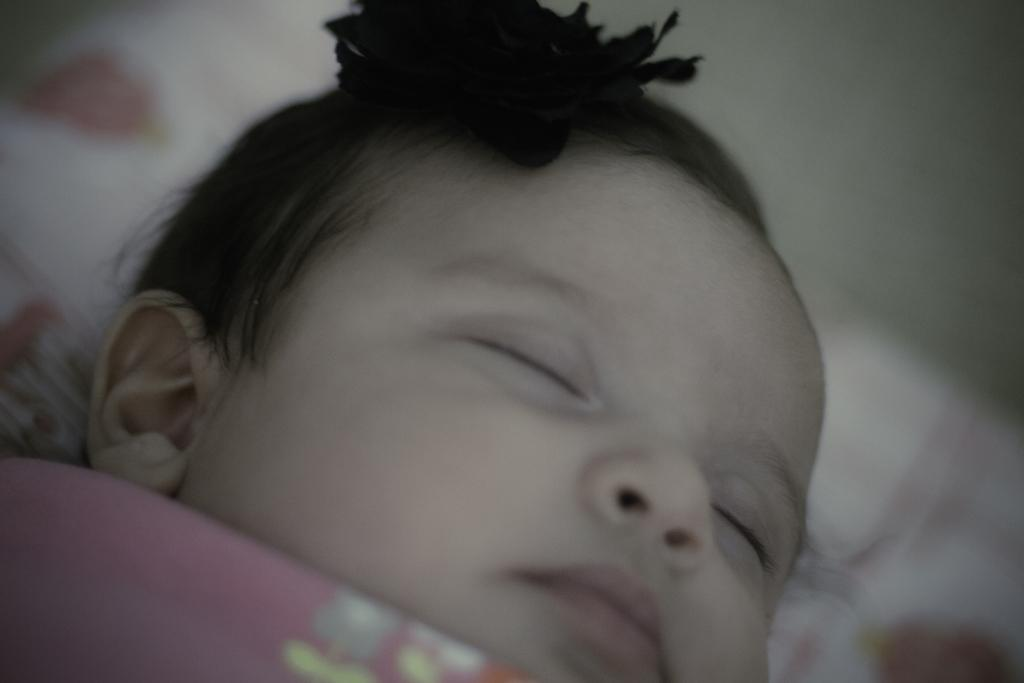What is the main subject of the image? The main subject of the image is a baby. What is the baby doing in the image? The baby is sleeping in the image. Where is the baby located in the image? The baby is in the center of the image. What advice does the baby's grandmother give in the image? There is no grandmother present in the image, and therefore no advice can be given. How many toes does the baby have in the image? The image does not show the baby's toes, so it cannot be determined from the image. 